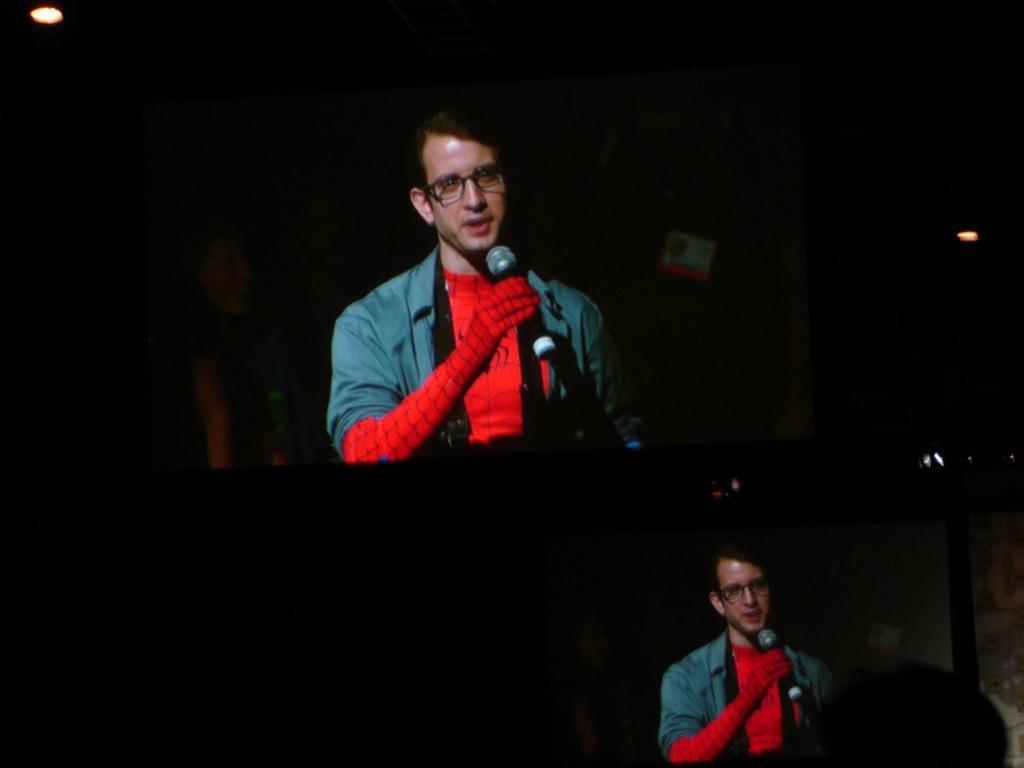How many screens are present in the image? There are two screens in the image. What can be seen in the background of the image? There are lights in the background of the image. How would you describe the overall lighting in the image? The image is dark. What is happening on the screens? A person is visible on the screens. What is the person holding in his hand? The person is holding a mic in his hand. What time of day is it in the image, as indicated by the hour on the clock? There is no clock present in the image, so we cannot determine the time of day. What type of rod is being used by the person on the screens? The person on the screens is holding a mic, not a rod. 